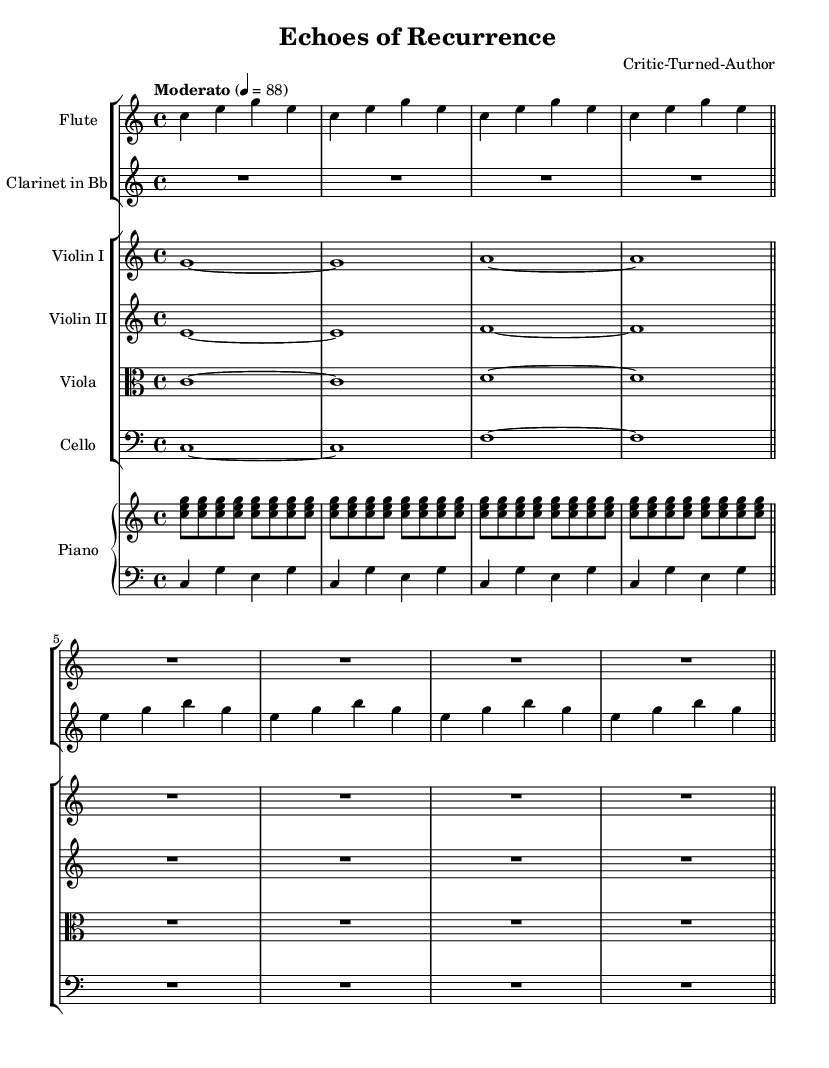What is the key signature of this music? The key signature is indicated at the beginning of the staff and is C major, which has no sharps or flats.
Answer: C major What is the time signature of this music? The time signature is shown at the beginning of the music and is 4/4, meaning there are four beats in each measure.
Answer: 4/4 What is the tempo marking for this symphony? The tempo marking appears in Italian at the beginning and denotes "Moderato," which indicates a moderate speed.
Answer: Moderato How many measures are in the flute part? Counting the measures in the flute part yields a total of four measures before the rest (R) for four beats in the fourth measure, confirming there are four complete measures.
Answer: 4 What is the rhythmic pattern used in the piano right hand? The pattern used in the piano right hand consists of repeating chords, specifically the notes C, E, and G, played as eighth notes and grouped in sets of four.
Answer: Repeating chords Which instrument plays the longest held note in this piece? Looking at the lengths of notes in the parts, the violin I plays a whole note G without rest, making it the longest held note in this excerpt.
Answer: Violin I Does the cello part feature any rests? Upon examining the cello part, there is an indication of rest with a whole rest symbol in the fourth measure, confirming the presence of a rest.
Answer: Yes 